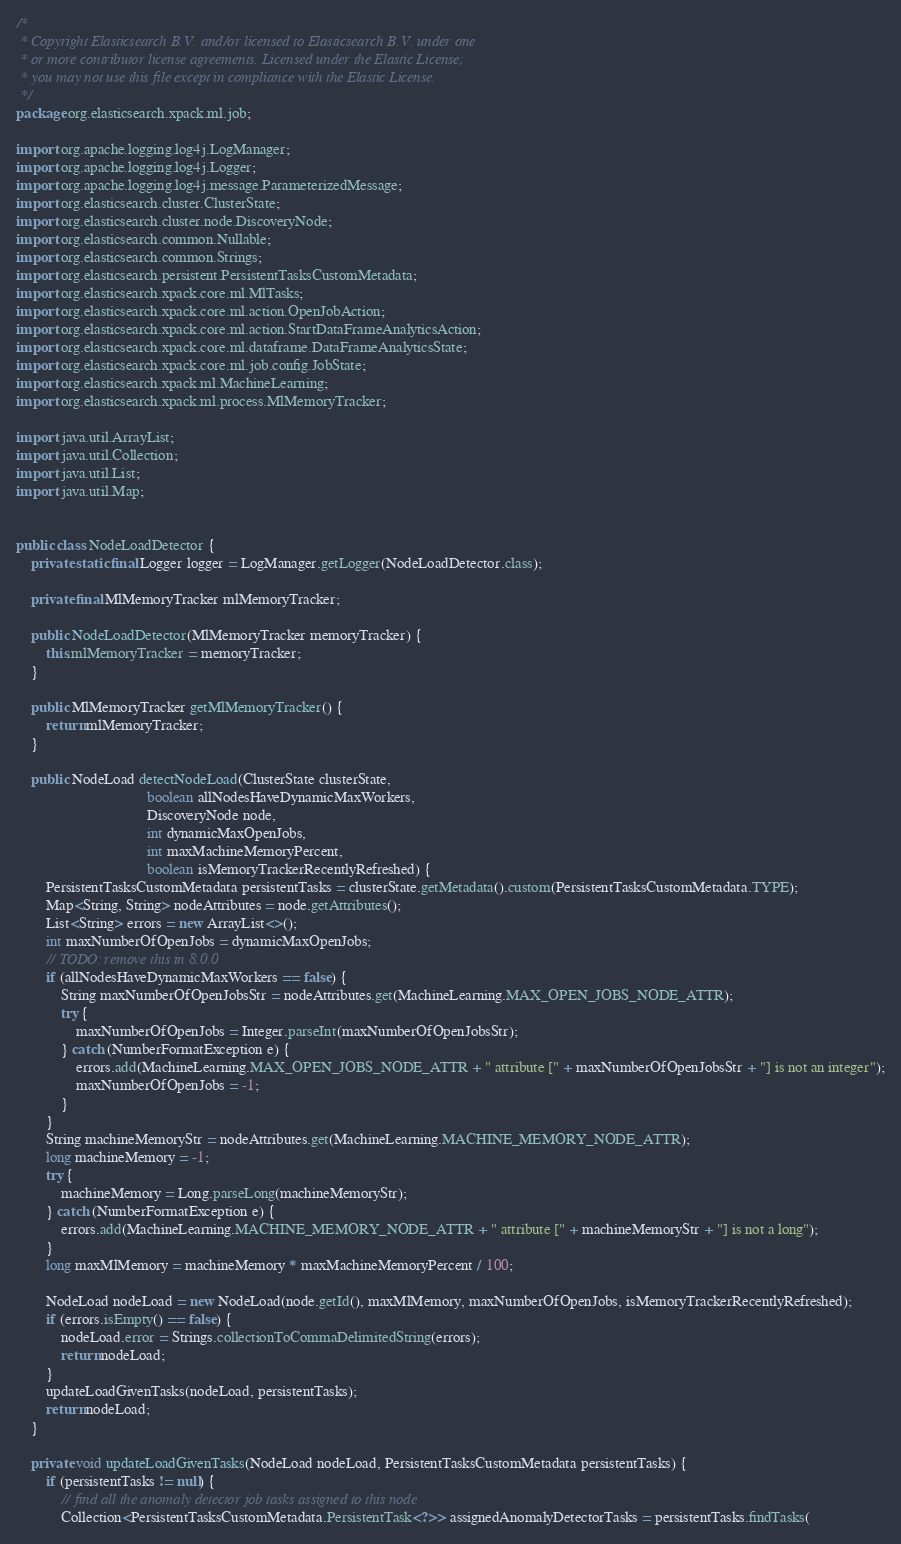<code> <loc_0><loc_0><loc_500><loc_500><_Java_>/*
 * Copyright Elasticsearch B.V. and/or licensed to Elasticsearch B.V. under one
 * or more contributor license agreements. Licensed under the Elastic License;
 * you may not use this file except in compliance with the Elastic License.
 */
package org.elasticsearch.xpack.ml.job;

import org.apache.logging.log4j.LogManager;
import org.apache.logging.log4j.Logger;
import org.apache.logging.log4j.message.ParameterizedMessage;
import org.elasticsearch.cluster.ClusterState;
import org.elasticsearch.cluster.node.DiscoveryNode;
import org.elasticsearch.common.Nullable;
import org.elasticsearch.common.Strings;
import org.elasticsearch.persistent.PersistentTasksCustomMetadata;
import org.elasticsearch.xpack.core.ml.MlTasks;
import org.elasticsearch.xpack.core.ml.action.OpenJobAction;
import org.elasticsearch.xpack.core.ml.action.StartDataFrameAnalyticsAction;
import org.elasticsearch.xpack.core.ml.dataframe.DataFrameAnalyticsState;
import org.elasticsearch.xpack.core.ml.job.config.JobState;
import org.elasticsearch.xpack.ml.MachineLearning;
import org.elasticsearch.xpack.ml.process.MlMemoryTracker;

import java.util.ArrayList;
import java.util.Collection;
import java.util.List;
import java.util.Map;


public class NodeLoadDetector {
    private static final Logger logger = LogManager.getLogger(NodeLoadDetector.class);

    private final MlMemoryTracker mlMemoryTracker;

    public NodeLoadDetector(MlMemoryTracker memoryTracker) {
        this.mlMemoryTracker = memoryTracker;
    }

    public MlMemoryTracker getMlMemoryTracker() {
        return mlMemoryTracker;
    }

    public NodeLoad detectNodeLoad(ClusterState clusterState,
                                   boolean allNodesHaveDynamicMaxWorkers,
                                   DiscoveryNode node,
                                   int dynamicMaxOpenJobs,
                                   int maxMachineMemoryPercent,
                                   boolean isMemoryTrackerRecentlyRefreshed) {
        PersistentTasksCustomMetadata persistentTasks = clusterState.getMetadata().custom(PersistentTasksCustomMetadata.TYPE);
        Map<String, String> nodeAttributes = node.getAttributes();
        List<String> errors = new ArrayList<>();
        int maxNumberOfOpenJobs = dynamicMaxOpenJobs;
        // TODO: remove this in 8.0.0
        if (allNodesHaveDynamicMaxWorkers == false) {
            String maxNumberOfOpenJobsStr = nodeAttributes.get(MachineLearning.MAX_OPEN_JOBS_NODE_ATTR);
            try {
                maxNumberOfOpenJobs = Integer.parseInt(maxNumberOfOpenJobsStr);
            } catch (NumberFormatException e) {
                errors.add(MachineLearning.MAX_OPEN_JOBS_NODE_ATTR + " attribute [" + maxNumberOfOpenJobsStr + "] is not an integer");
                maxNumberOfOpenJobs = -1;
            }
        }
        String machineMemoryStr = nodeAttributes.get(MachineLearning.MACHINE_MEMORY_NODE_ATTR);
        long machineMemory = -1;
        try {
            machineMemory = Long.parseLong(machineMemoryStr);
        } catch (NumberFormatException e) {
            errors.add(MachineLearning.MACHINE_MEMORY_NODE_ATTR + " attribute [" + machineMemoryStr + "] is not a long");
        }
        long maxMlMemory = machineMemory * maxMachineMemoryPercent / 100;

        NodeLoad nodeLoad = new NodeLoad(node.getId(), maxMlMemory, maxNumberOfOpenJobs, isMemoryTrackerRecentlyRefreshed);
        if (errors.isEmpty() == false) {
            nodeLoad.error = Strings.collectionToCommaDelimitedString(errors);
            return nodeLoad;
        }
        updateLoadGivenTasks(nodeLoad, persistentTasks);
        return nodeLoad;
    }

    private void updateLoadGivenTasks(NodeLoad nodeLoad, PersistentTasksCustomMetadata persistentTasks) {
        if (persistentTasks != null) {
            // find all the anomaly detector job tasks assigned to this node
            Collection<PersistentTasksCustomMetadata.PersistentTask<?>> assignedAnomalyDetectorTasks = persistentTasks.findTasks(</code> 